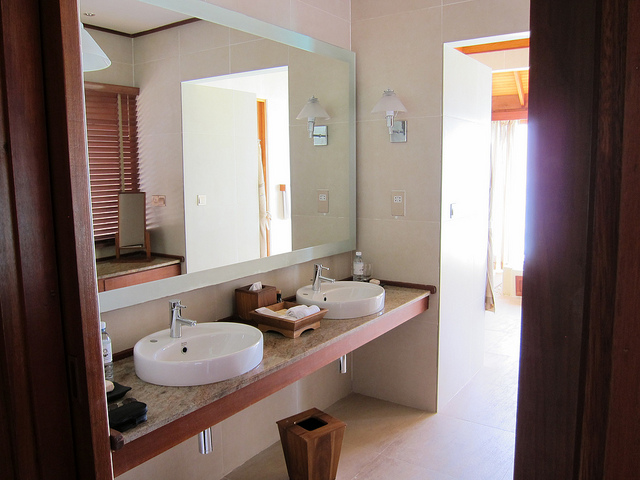Is the bathroom clean or dirty? The bathroom appears meticulously clean. The surfaces including the mirror, countertop, and floor show no signs of dirt or smudges, reflecting a well-maintained space. 